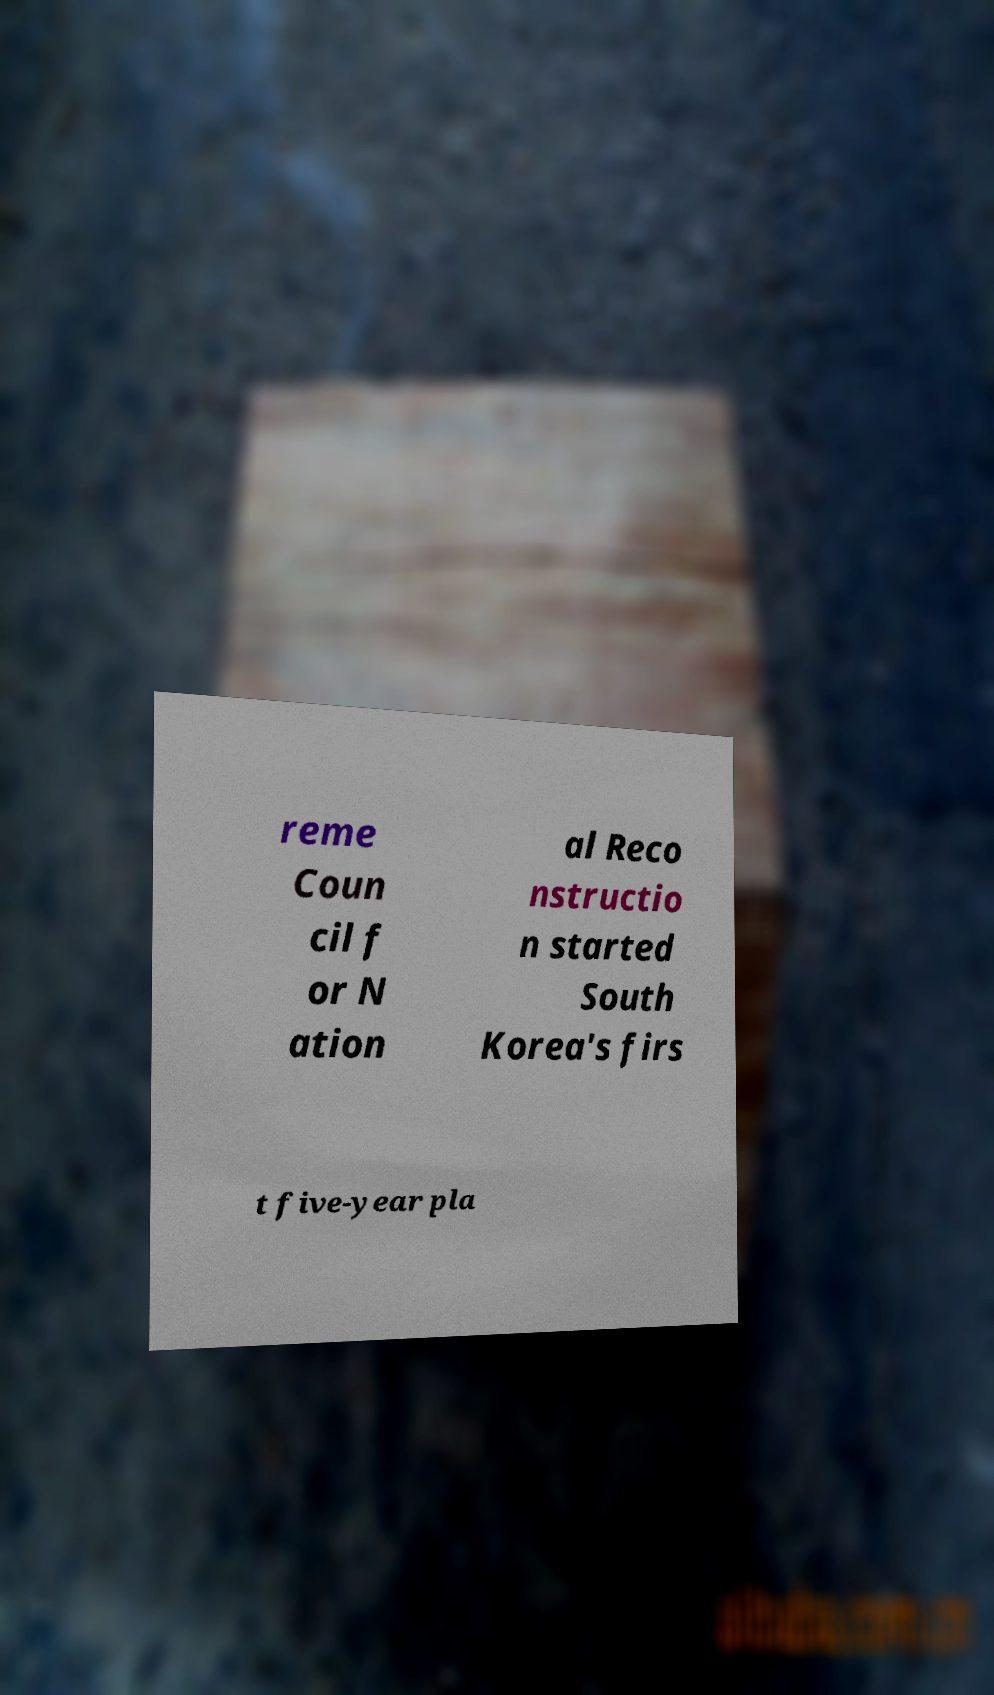Please identify and transcribe the text found in this image. reme Coun cil f or N ation al Reco nstructio n started South Korea's firs t five-year pla 